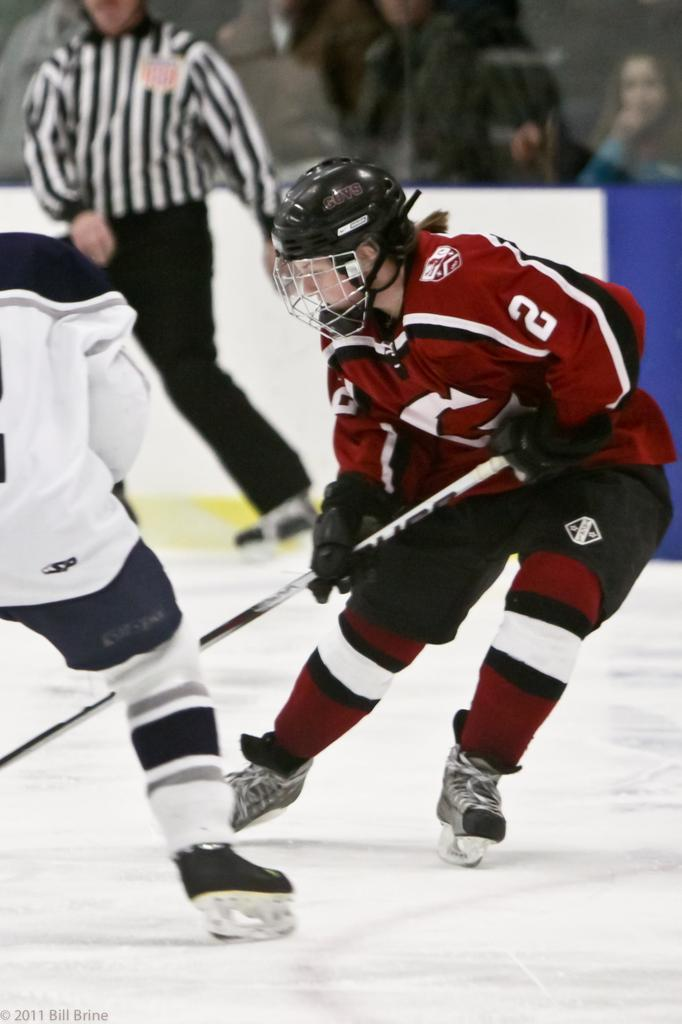What activity are the two persons in the image engaged in? The two persons in the image are playing ice hockey. What protective gear is one of the players wearing? One person is wearing a helmet. What equipment is the person with the helmet using? The person with the helmet is holding a stick. Can you describe the setting of the image? There are people visible in the background of the image. What type of coal is being used to fuel the horses in the image? There are no horses or coal present in the image; it features two persons playing ice hockey. What title does the person with the helmet hold in the image? There is no indication of any titles or positions in the image; it simply shows two persons playing ice hockey. 